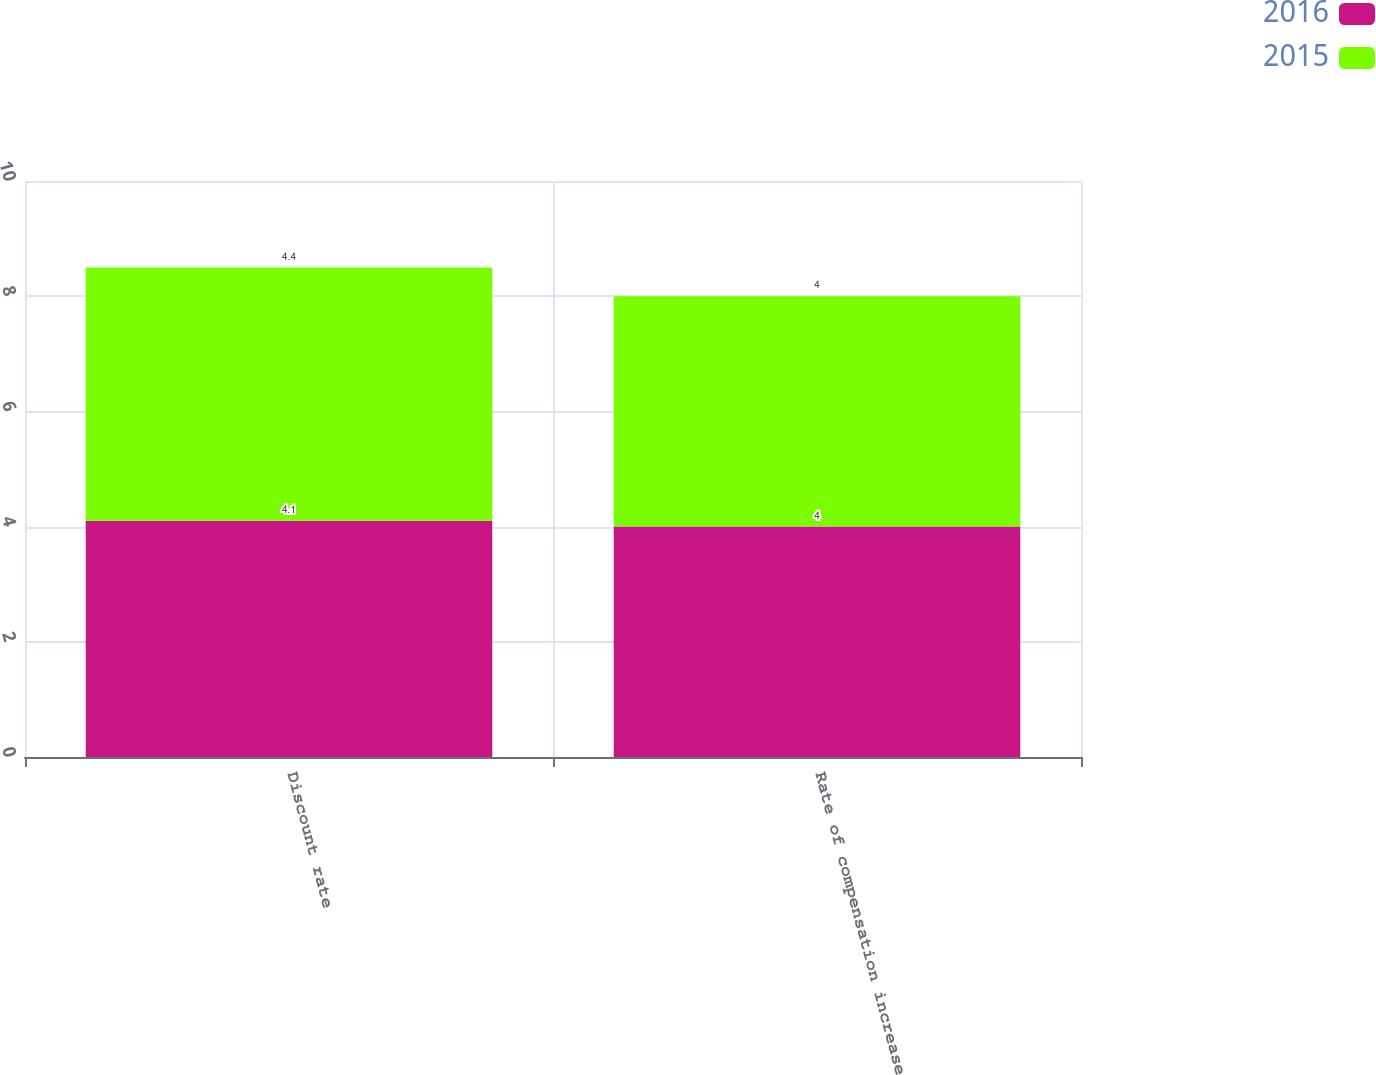Convert chart to OTSL. <chart><loc_0><loc_0><loc_500><loc_500><stacked_bar_chart><ecel><fcel>Discount rate<fcel>Rate of compensation increase<nl><fcel>2016<fcel>4.1<fcel>4<nl><fcel>2015<fcel>4.4<fcel>4<nl></chart> 